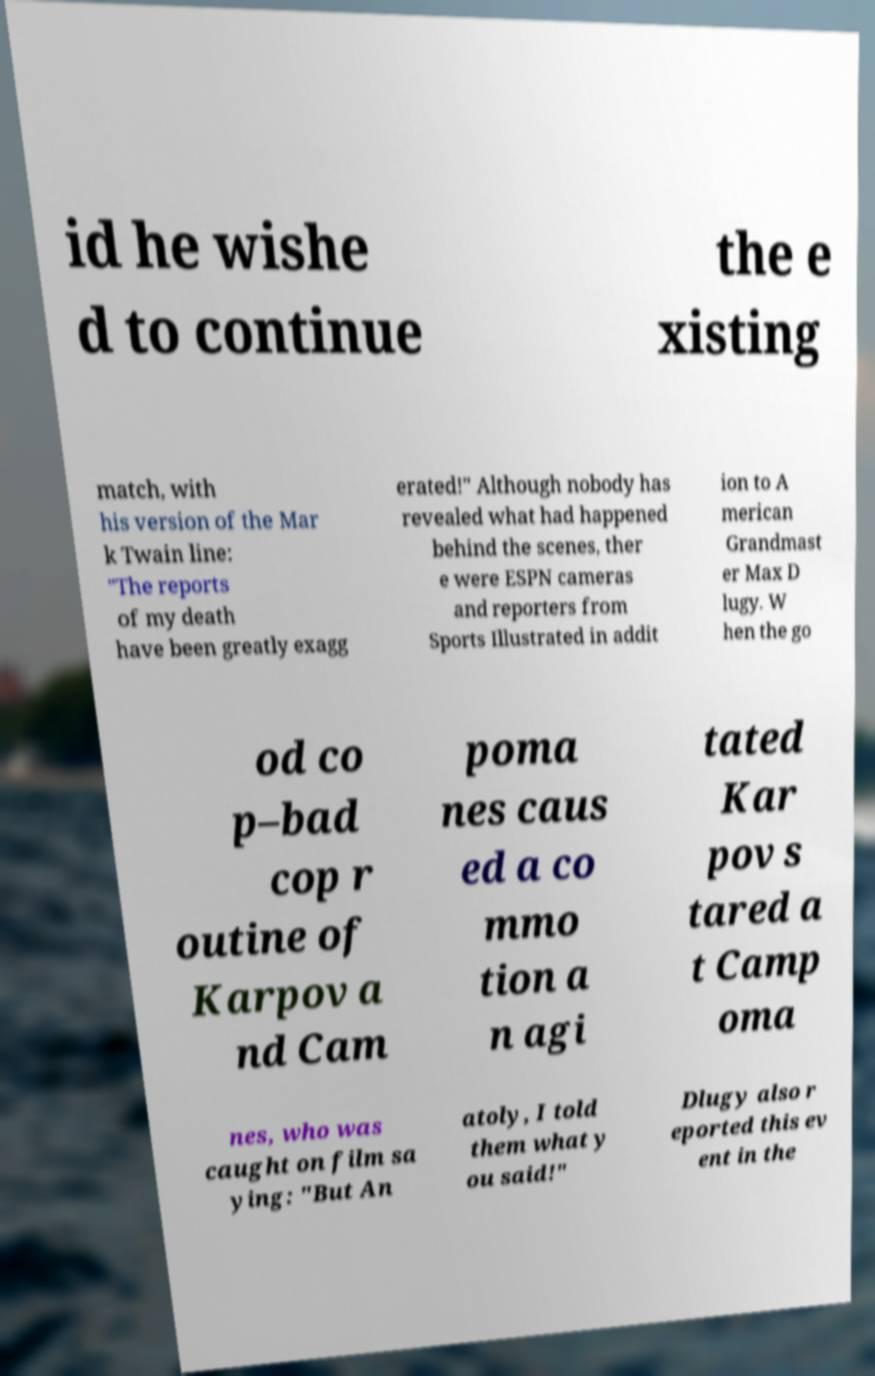For documentation purposes, I need the text within this image transcribed. Could you provide that? id he wishe d to continue the e xisting match, with his version of the Mar k Twain line: "The reports of my death have been greatly exagg erated!" Although nobody has revealed what had happened behind the scenes, ther e were ESPN cameras and reporters from Sports Illustrated in addit ion to A merican Grandmast er Max D lugy. W hen the go od co p–bad cop r outine of Karpov a nd Cam poma nes caus ed a co mmo tion a n agi tated Kar pov s tared a t Camp oma nes, who was caught on film sa ying: "But An atoly, I told them what y ou said!" Dlugy also r eported this ev ent in the 